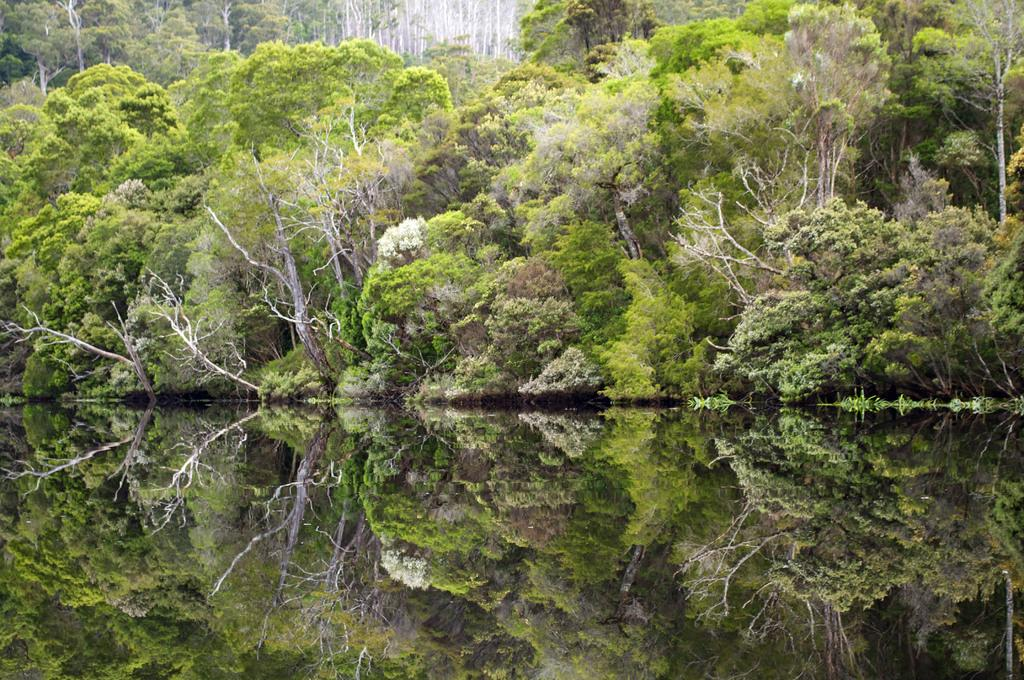What type of vegetation is present in the image? There are many trees in the image. What natural element is visible in the image besides trees? There is water visible in the image. Can you describe the interaction between the trees and the water in the image? The reflection of the trees can be seen in the water. How many beetles can be seen crawling on the tree in the image? There are no beetles visible in the image; it only features trees and water. 